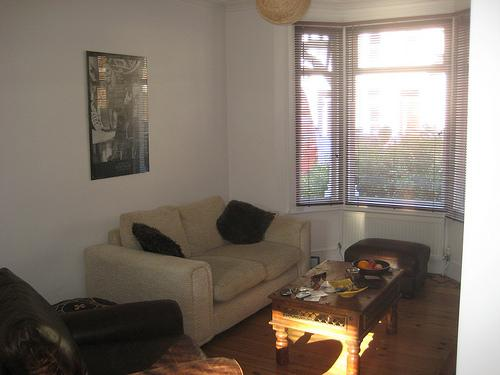Question: how is the sun shining?
Choices:
A. Through the trees.
B. Through the windows.
C. Over the hills.
D. On the water.
Answer with the letter. Answer: B Question: what color is the couch in the picture?
Choices:
A. White.
B. Black.
C. Green.
D. Beige.
Answer with the letter. Answer: D Question: what is the coffee table made of?
Choices:
A. Glass.
B. Wood.
C. Metal.
D. Plastic.
Answer with the letter. Answer: B Question: when was this picture taken?
Choices:
A. While the room was empty.
B. Yesterday.
C. Last week.
D. In the morning.
Answer with the letter. Answer: A Question: where was this picture taken?
Choices:
A. On the deck.
B. In a living room.
C. At the park.
D. On the beach.
Answer with the letter. Answer: B 